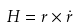<formula> <loc_0><loc_0><loc_500><loc_500>H = r \times \dot { r }</formula> 